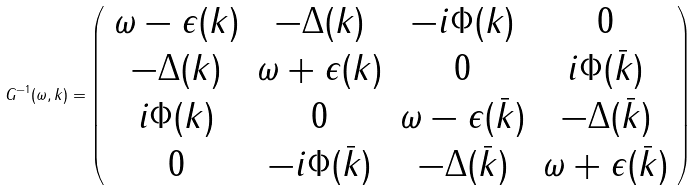<formula> <loc_0><loc_0><loc_500><loc_500>G ^ { - 1 } ( \omega , { k } ) = \left ( \begin{array} { c c c c } \omega - \epsilon ( { k } ) & - \Delta ( { k } ) & - i \Phi ( { k } ) & 0 \\ - \Delta ( { k } ) & \omega + \epsilon ( { k } ) & 0 & i \Phi ( { \bar { k } } ) \\ i \Phi ( { k } ) & 0 & \omega - \epsilon ( { \bar { k } } ) & - \Delta ( { \bar { k } } ) \\ 0 & - i \Phi ( { \bar { k } } ) & - \Delta ( { \bar { k } } ) & \omega + \epsilon ( { \bar { k } } ) \end{array} \right )</formula> 